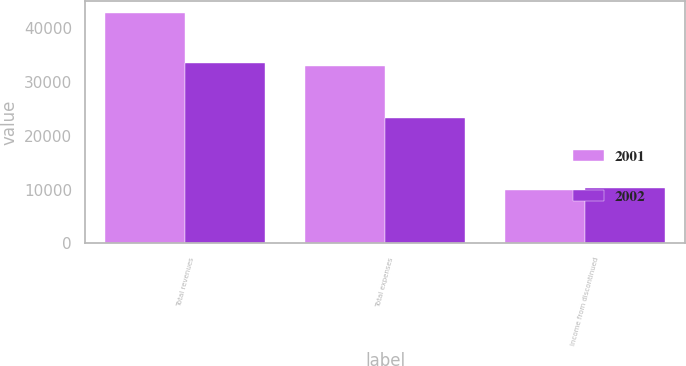<chart> <loc_0><loc_0><loc_500><loc_500><stacked_bar_chart><ecel><fcel>Total revenues<fcel>Total expenses<fcel>Income from discontinued<nl><fcel>2001<fcel>42831<fcel>32947<fcel>9884<nl><fcel>2002<fcel>33612<fcel>23270<fcel>10342<nl></chart> 